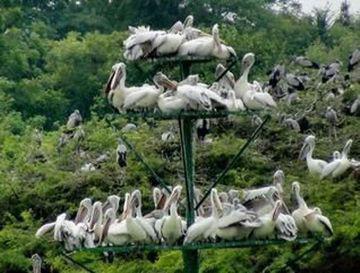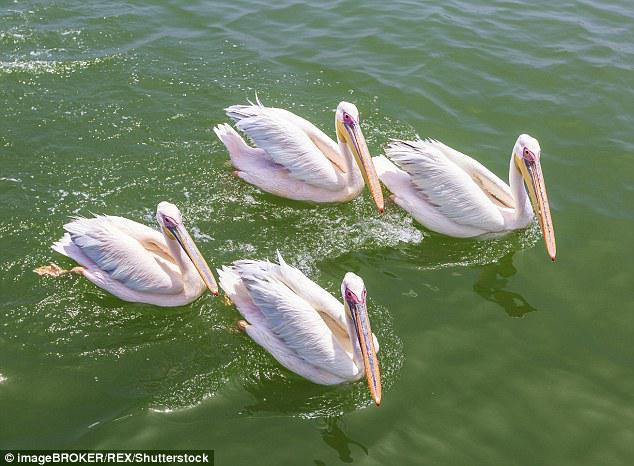The first image is the image on the left, the second image is the image on the right. Given the left and right images, does the statement "There  are at least 20 pelicans with white feathers and orange beak sitting together with no water in sight." hold true? Answer yes or no. Yes. The first image is the image on the left, the second image is the image on the right. Analyze the images presented: Is the assertion "In at least one photo, there are fewer than 5 birds." valid? Answer yes or no. Yes. 